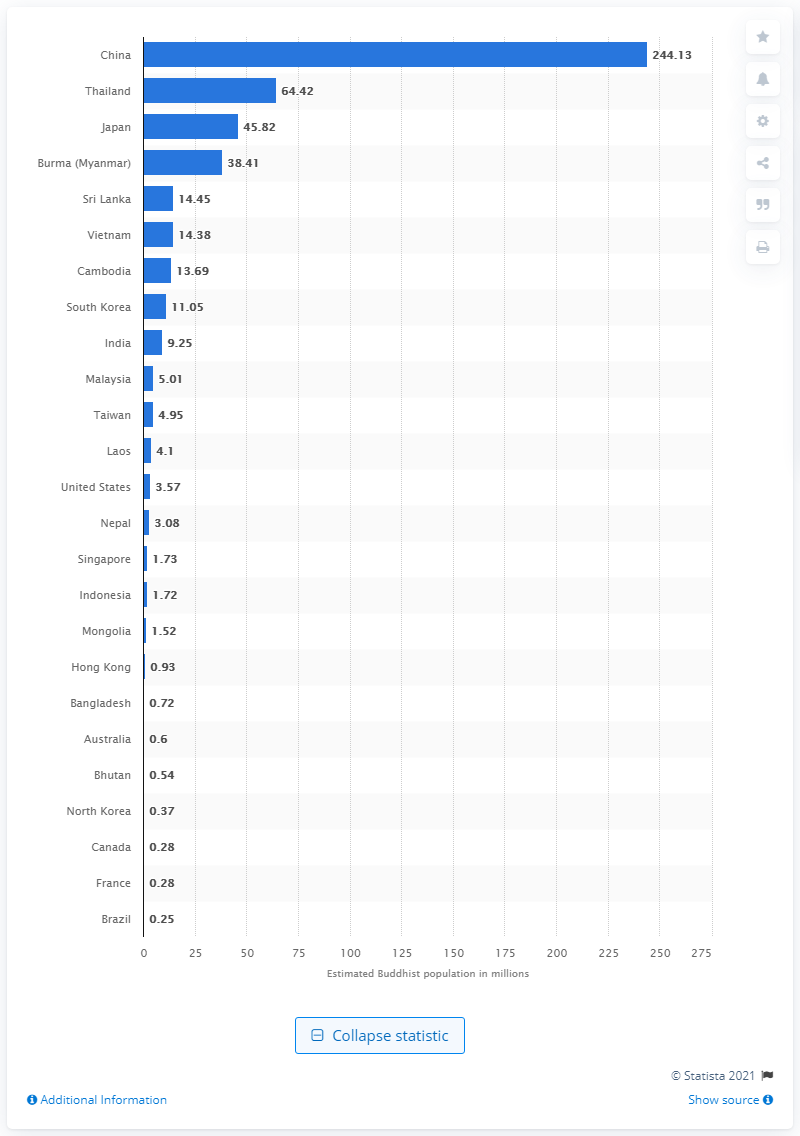Give some essential details in this illustration. In 2010, it is estimated that 244.13 Buddhists lived in China. 